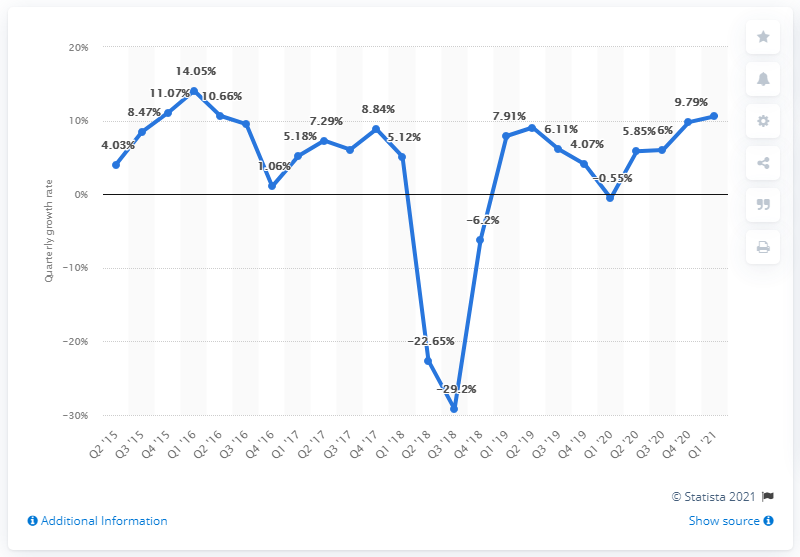Point out several critical features in this image. During the most recent quarter, there was a significant increase in the growth of mobile apps on the Google Play platform, with a growth of 10.6%. 